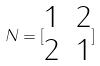<formula> <loc_0><loc_0><loc_500><loc_500>N = [ \begin{matrix} 1 & 2 \\ 2 & 1 \end{matrix} ]</formula> 